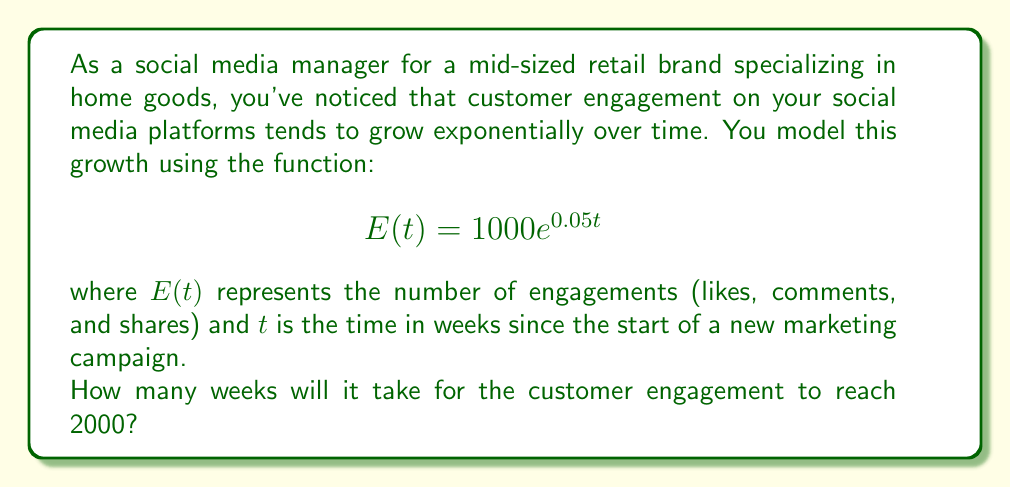Could you help me with this problem? To solve this problem, we need to use the exponential function given and solve for $t$ when $E(t) = 2000$. Let's break it down step-by-step:

1) We start with the equation:
   $$E(t) = 1000e^{0.05t}$$

2) We want to find $t$ when $E(t) = 2000$, so we set up the equation:
   $$2000 = 1000e^{0.05t}$$

3) Divide both sides by 1000:
   $$2 = e^{0.05t}$$

4) Take the natural logarithm of both sides:
   $$\ln(2) = \ln(e^{0.05t})$$

5) Using the property of logarithms that $\ln(e^x) = x$, we get:
   $$\ln(2) = 0.05t$$

6) Solve for $t$ by dividing both sides by 0.05:
   $$t = \frac{\ln(2)}{0.05}$$

7) Calculate the result:
   $$t \approx 13.86$$

8) Since we're dealing with weeks, we round up to the nearest whole number:
   $$t = 14$$

Therefore, it will take 14 weeks for the customer engagement to reach 2000.
Answer: 14 weeks 